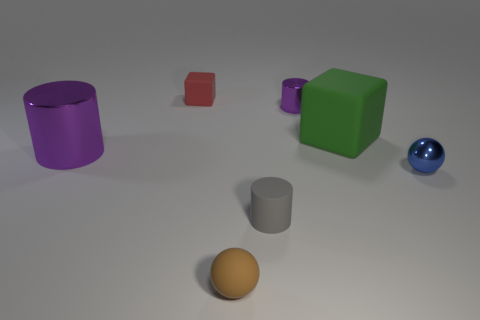Can you tell me the colors of the various objects in the scene? Certainly! In the scene, there is a purple cylinder, a red small cube, a green large cube, a silver cylinder, a blue sphere, and a brown hemisphere. 